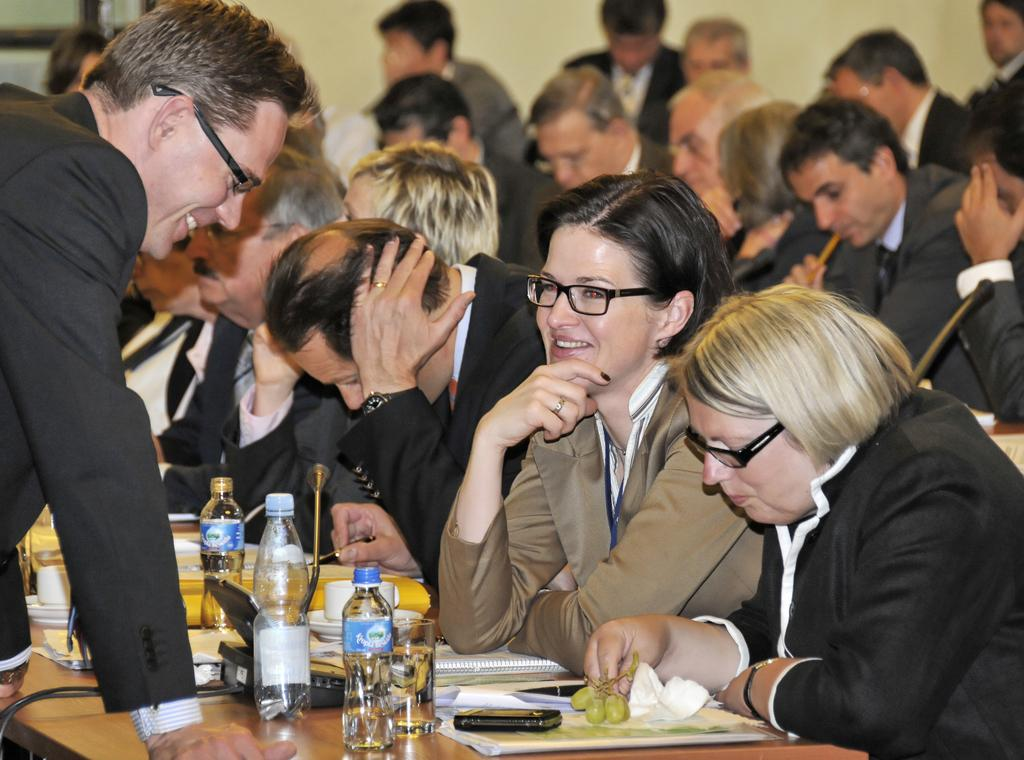What are the people in the image doing? The people in the image are sitting on the right side. Can you describe the person standing in the image? There is a person standing with a smile in the image. What objects can be seen on the table in the image? Bottles, files, glass, and telephones are visible on the table in the image. What type of destruction can be seen on the table in the image? There is no destruction present on the table in the image; it features bottles, files, glass, and telephones. How many women are visible in the image? The provided facts do not mention the gender of the people in the image, so it cannot be determined from the image. 